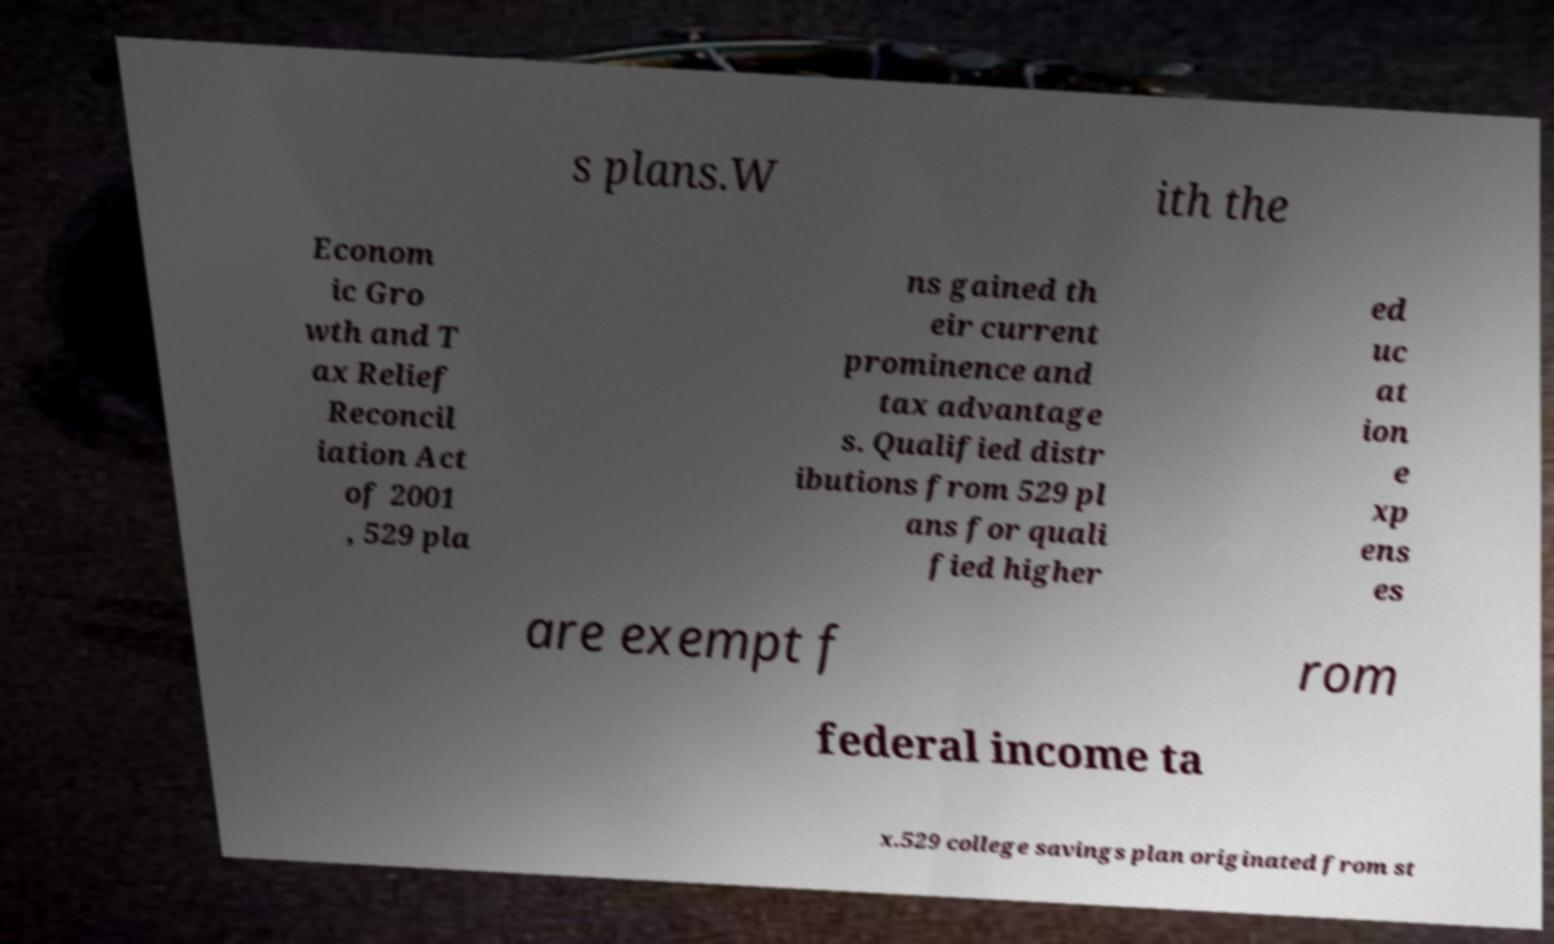For documentation purposes, I need the text within this image transcribed. Could you provide that? s plans.W ith the Econom ic Gro wth and T ax Relief Reconcil iation Act of 2001 , 529 pla ns gained th eir current prominence and tax advantage s. Qualified distr ibutions from 529 pl ans for quali fied higher ed uc at ion e xp ens es are exempt f rom federal income ta x.529 college savings plan originated from st 